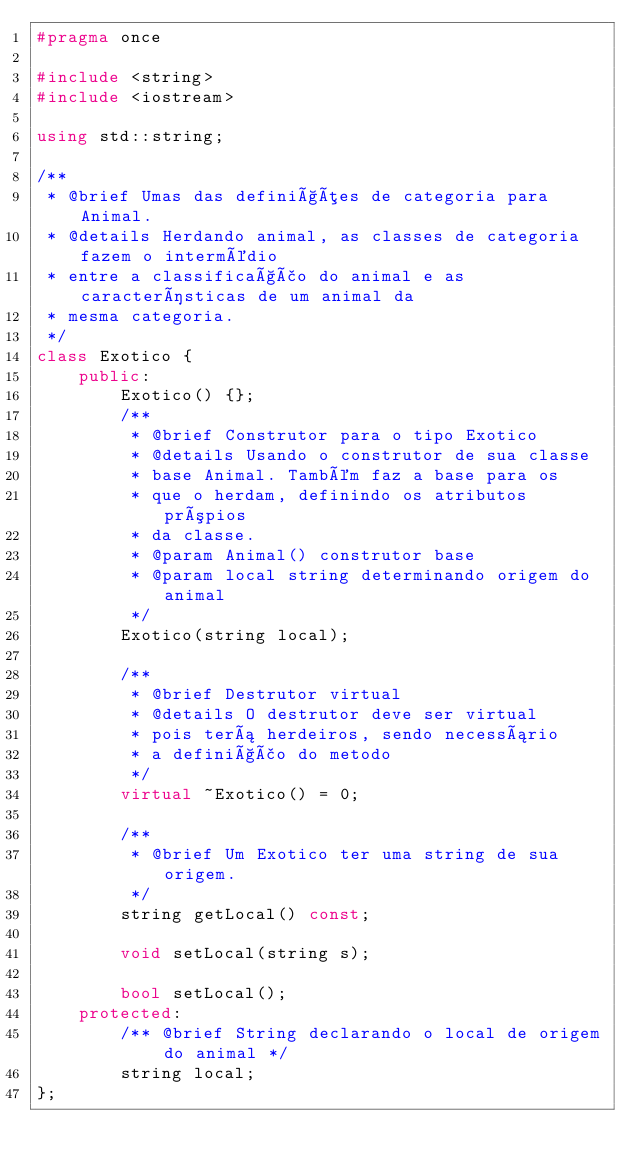<code> <loc_0><loc_0><loc_500><loc_500><_C++_>#pragma once

#include <string>
#include <iostream>

using std::string;

/**
 * @brief Umas das definições de categoria para Animal.
 * @details Herdando animal, as classes de categoria fazem o intermédio
 * entre a classificação do animal e as características de um animal da
 * mesma categoria.
 */
class Exotico {
    public:
        Exotico() {};
        /**
         * @brief Construtor para o tipo Exotico
         * @details Usando o construtor de sua classe
         * base Animal. Também faz a base para os
         * que o herdam, definindo os atributos própios
         * da classe.
         * @param Animal() construtor base
         * @param local string determinando origem do animal
         */
        Exotico(string local);

        /**
         * @brief Destrutor virtual
         * @details O destrutor deve ser virtual
         * pois terá herdeiros, sendo necessário
         * a definição do metodo
         */
        virtual ~Exotico() = 0;

        /**
         * @brief Um Exotico ter uma string de sua origem.
         */
        string getLocal() const;
        
        void setLocal(string s);

        bool setLocal();
    protected:
        /** @brief String declarando o local de origem do animal */
        string local;
};</code> 